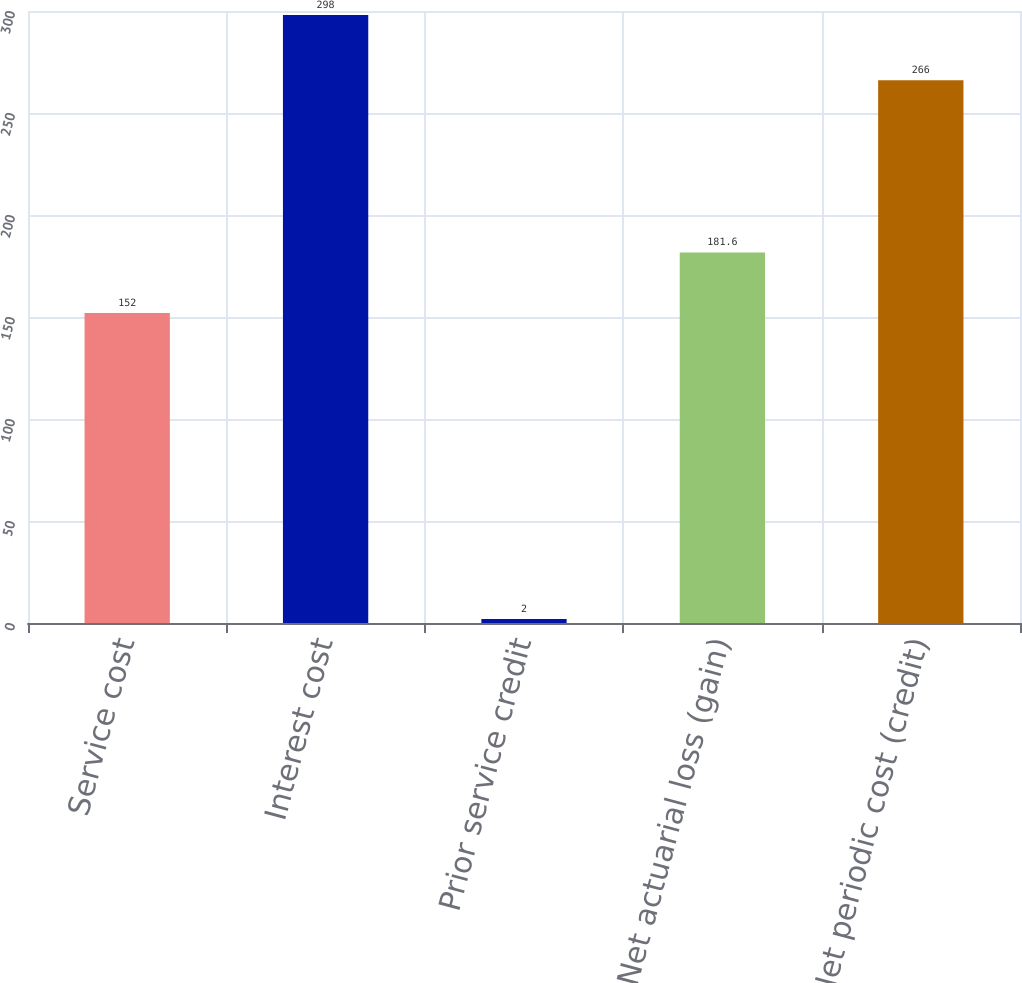Convert chart. <chart><loc_0><loc_0><loc_500><loc_500><bar_chart><fcel>Service cost<fcel>Interest cost<fcel>Prior service credit<fcel>Net actuarial loss (gain)<fcel>Net periodic cost (credit)<nl><fcel>152<fcel>298<fcel>2<fcel>181.6<fcel>266<nl></chart> 